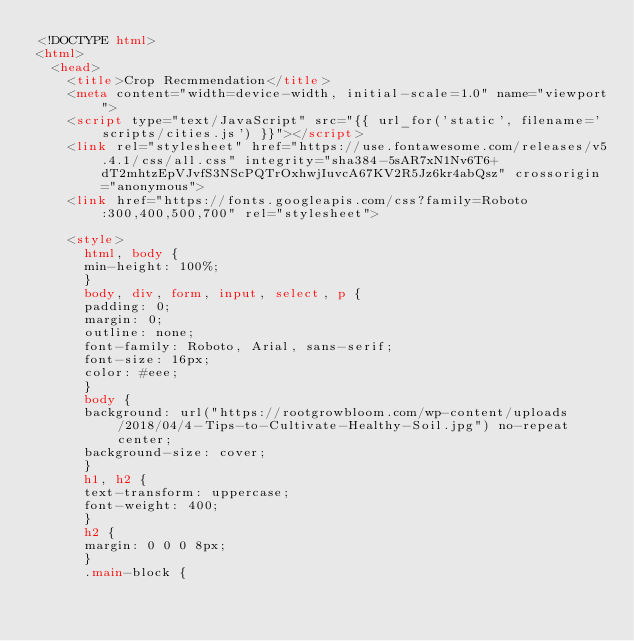<code> <loc_0><loc_0><loc_500><loc_500><_HTML_><!DOCTYPE html>
<html>
  <head>
    <title>Crop Recmmendation</title>
    <meta content="width=device-width, initial-scale=1.0" name="viewport">
    <script type="text/JavaScript" src="{{ url_for('static', filename='scripts/cities.js') }}"></script>
    <link rel="stylesheet" href="https://use.fontawesome.com/releases/v5.4.1/css/all.css" integrity="sha384-5sAR7xN1Nv6T6+dT2mhtzEpVJvfS3NScPQTrOxhwjIuvcA67KV2R5Jz6kr4abQsz" crossorigin="anonymous">
    <link href="https://fonts.googleapis.com/css?family=Roboto:300,400,500,700" rel="stylesheet">

    <style>
      html, body {
      min-height: 100%;
      }
      body, div, form, input, select, p { 
      padding: 0;
      margin: 0;
      outline: none;
      font-family: Roboto, Arial, sans-serif;
      font-size: 16px;
      color: #eee;
      }
      body {
      background: url("https://rootgrowbloom.com/wp-content/uploads/2018/04/4-Tips-to-Cultivate-Healthy-Soil.jpg") no-repeat center;
      background-size: cover;
      }
      h1, h2 {
      text-transform: uppercase;
      font-weight: 400;
      }
      h2 {
      margin: 0 0 0 8px;
      }
      .main-block {</code> 